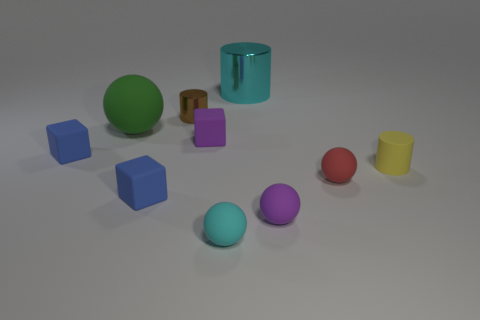Subtract all tiny matte balls. How many balls are left? 1 Subtract 2 balls. How many balls are left? 2 Subtract all blue spheres. Subtract all gray cubes. How many spheres are left? 4 Subtract all cubes. How many objects are left? 7 Subtract all big red rubber cubes. Subtract all brown cylinders. How many objects are left? 9 Add 1 red things. How many red things are left? 2 Add 10 large yellow metallic things. How many large yellow metallic things exist? 10 Subtract 0 gray spheres. How many objects are left? 10 